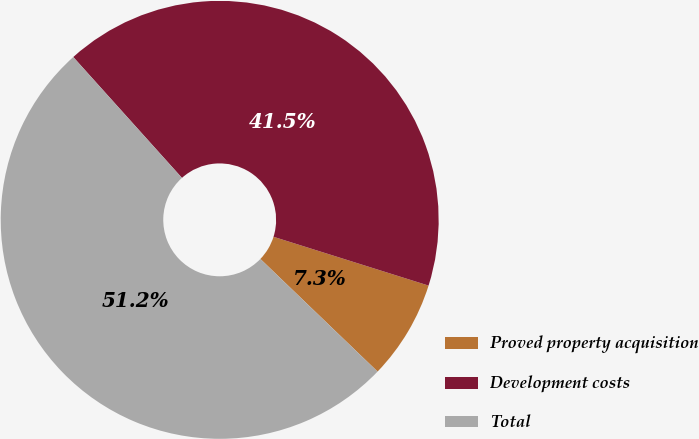<chart> <loc_0><loc_0><loc_500><loc_500><pie_chart><fcel>Proved property acquisition<fcel>Development costs<fcel>Total<nl><fcel>7.33%<fcel>41.51%<fcel>51.16%<nl></chart> 